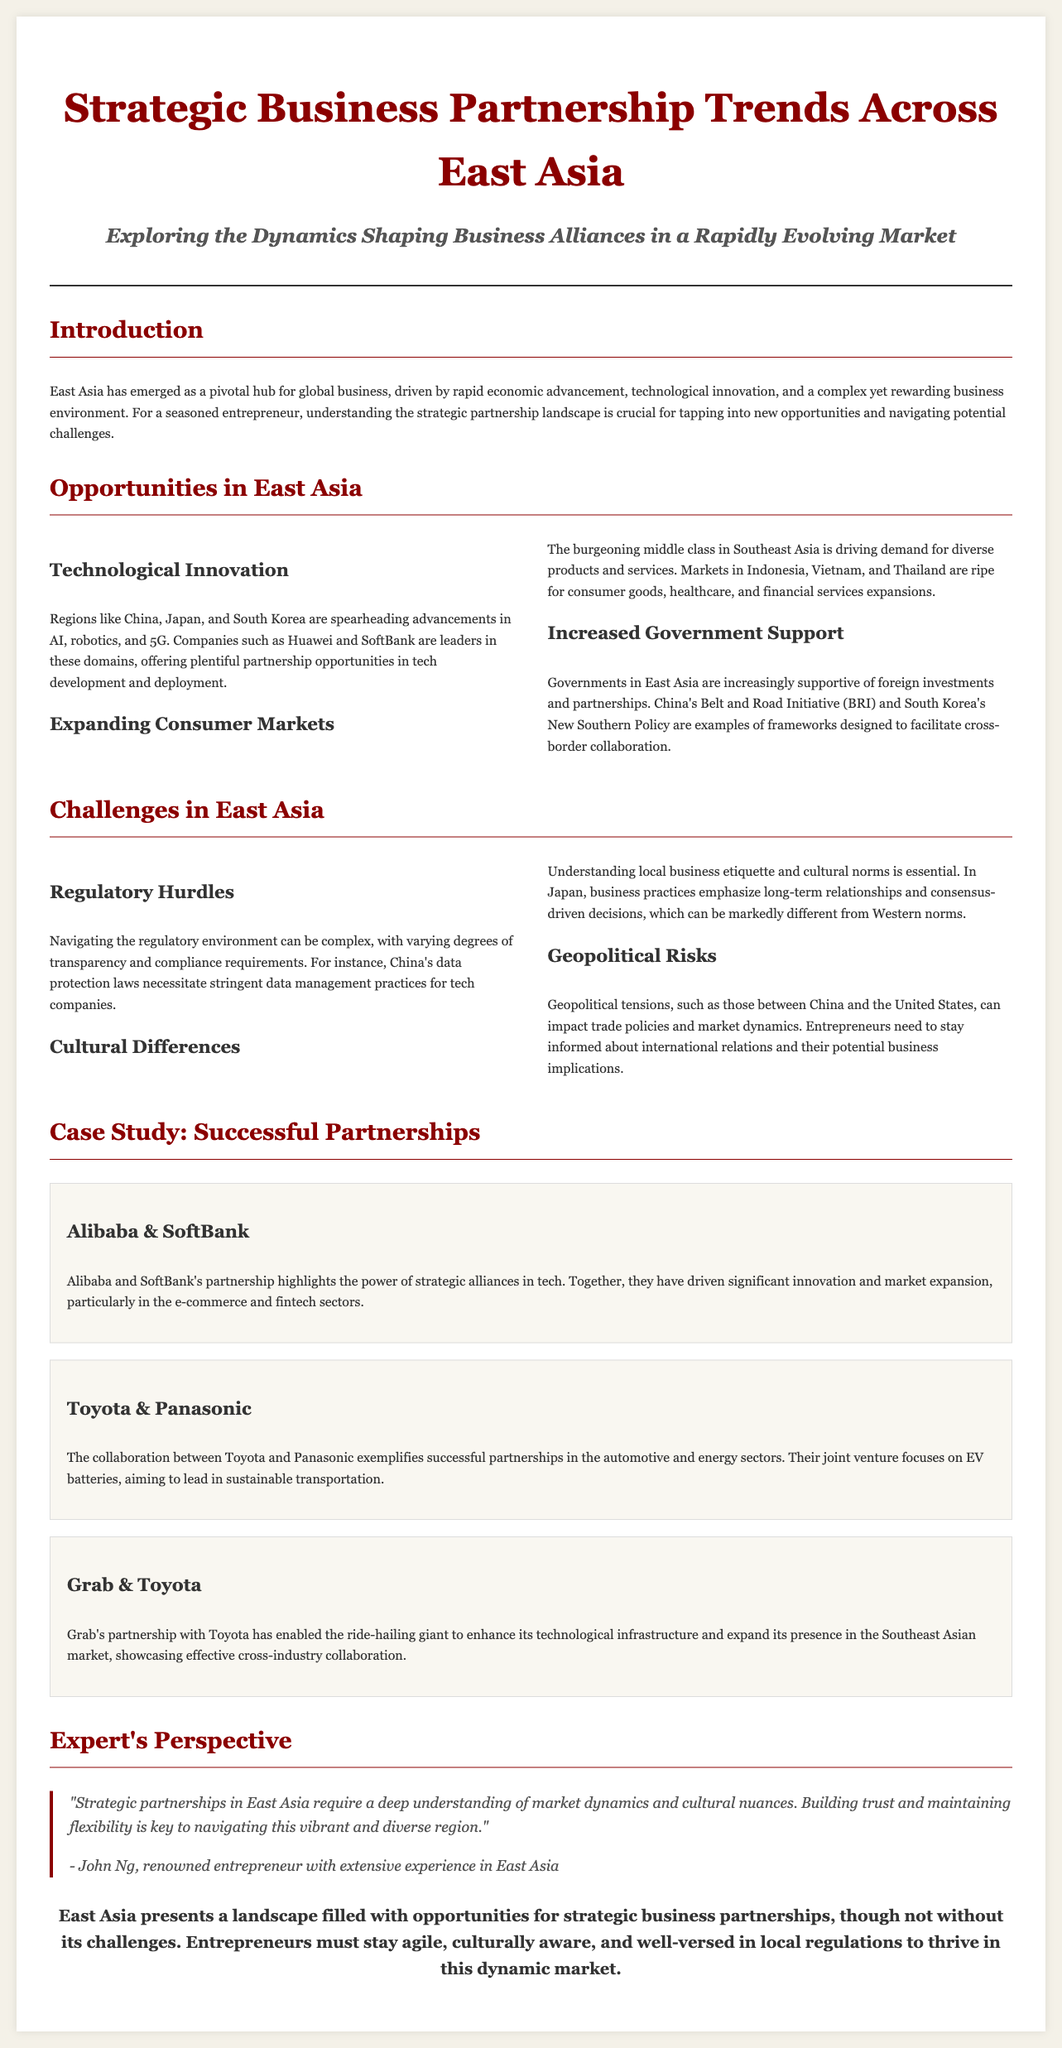what is the title of the document? The title of the document is prominently displayed at the top and provides the main focus of the article.
Answer: Strategic Business Partnership Trends Across East Asia which countries are mentioned as leaders in technological innovation? The document lists specific countries that are at the forefront of technological advancements in the region.
Answer: China, Japan, South Korea what is the primary challenge related to regulatory issues? The document specifies a particular area of concern that entrepreneurs face when navigating regulations in East Asia.
Answer: Data protection laws who are the partners in the case study about EV batteries? The case study highlights a specific collaboration between two companies in the automotive and energy sectors.
Answer: Toyota & Panasonic what is a key factor in establishing successful partnerships according to the expert? The quote from the expert emphasizes an important quality necessary for building strategic partnerships in East Asia.
Answer: Trust which Indonesian sector is mentioned as experiencing demand due to the expanding middle class? The document highlights sectors that are growing due to shifts in consumer patterns in Southeast Asia.
Answer: Consumer goods how many case studies are presented in the article? The section on case studies lists the number of partnerships and their significance in the business landscape.
Answer: Three what initiative is mentioned as a framework to facilitate cross-border collaboration? The document provides an example of a government-led initiative aimed at improving business partnerships in East Asia.
Answer: Belt and Road Initiative 